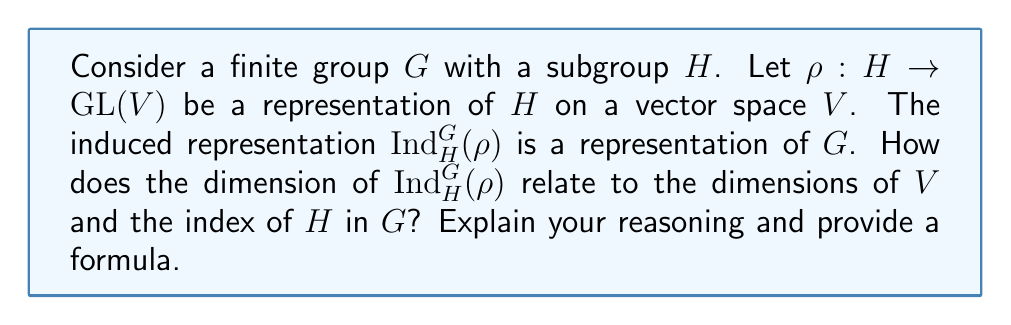Teach me how to tackle this problem. Let's approach this step-by-step:

1) First, recall that the induced representation $\text{Ind}_H^G(\rho)$ is defined on the vector space:

   $$W = \{f: G \rightarrow V \mid f(hg) = \rho(h)f(g) \text{ for all } h \in H, g \in G\}$$

2) To determine the dimension of $W$, we need to consider how many independent functions $f$ we can define.

3) Let $\{g_1, g_2, ..., g_n\}$ be a set of representatives for the left cosets of $H$ in $G$, where $n = [G:H]$ is the index of $H$ in $G$.

4) Any function $f \in W$ is completely determined by its values on these representatives, because for any $g \in G$, we can write $g = hg_i$ for some $h \in H$ and some representative $g_i$, and then:

   $$f(g) = f(hg_i) = \rho(h)f(g_i)$$

5) For each $g_i$, $f(g_i)$ can be any vector in $V$. This means we have $\dim(V)$ degrees of freedom for each of the $n$ representatives.

6) Therefore, the total dimension of $W$ is:

   $$\dim(W) = n \cdot \dim(V) = [G:H] \cdot \dim(V)$$

This formula shows how the dimension of the induced representation relates to the dimension of the original representation and the index of the subgroup.
Answer: $\dim(\text{Ind}_H^G(\rho)) = [G:H] \cdot \dim(V)$ 